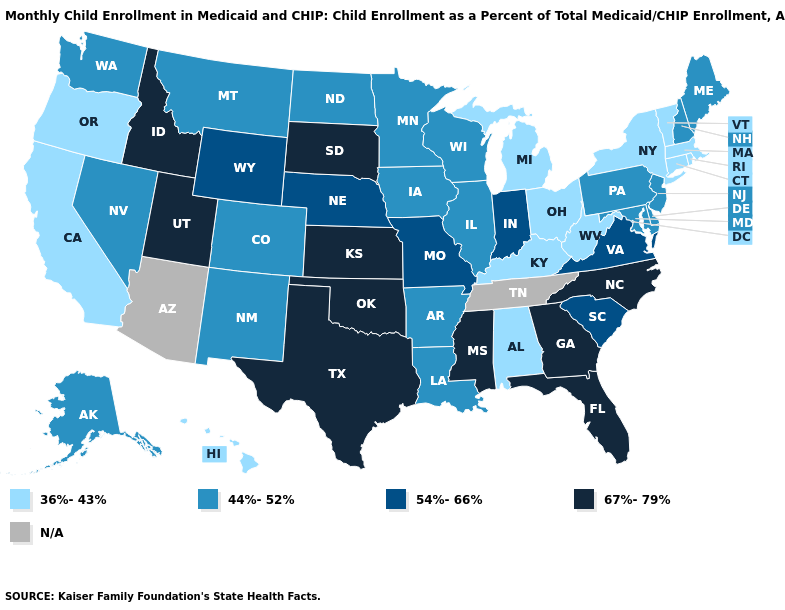Among the states that border Kansas , which have the highest value?
Concise answer only. Oklahoma. What is the lowest value in the West?
Be succinct. 36%-43%. Among the states that border Utah , does Idaho have the highest value?
Short answer required. Yes. Name the states that have a value in the range 67%-79%?
Short answer required. Florida, Georgia, Idaho, Kansas, Mississippi, North Carolina, Oklahoma, South Dakota, Texas, Utah. Name the states that have a value in the range 44%-52%?
Quick response, please. Alaska, Arkansas, Colorado, Delaware, Illinois, Iowa, Louisiana, Maine, Maryland, Minnesota, Montana, Nevada, New Hampshire, New Jersey, New Mexico, North Dakota, Pennsylvania, Washington, Wisconsin. Among the states that border Florida , does Georgia have the highest value?
Concise answer only. Yes. What is the value of North Carolina?
Concise answer only. 67%-79%. Name the states that have a value in the range 54%-66%?
Short answer required. Indiana, Missouri, Nebraska, South Carolina, Virginia, Wyoming. Does Vermont have the highest value in the USA?
Keep it brief. No. Which states have the highest value in the USA?
Answer briefly. Florida, Georgia, Idaho, Kansas, Mississippi, North Carolina, Oklahoma, South Dakota, Texas, Utah. What is the value of Wyoming?
Answer briefly. 54%-66%. What is the value of Alaska?
Short answer required. 44%-52%. Name the states that have a value in the range 36%-43%?
Answer briefly. Alabama, California, Connecticut, Hawaii, Kentucky, Massachusetts, Michigan, New York, Ohio, Oregon, Rhode Island, Vermont, West Virginia. Does Maine have the lowest value in the USA?
Quick response, please. No. What is the highest value in the USA?
Give a very brief answer. 67%-79%. 